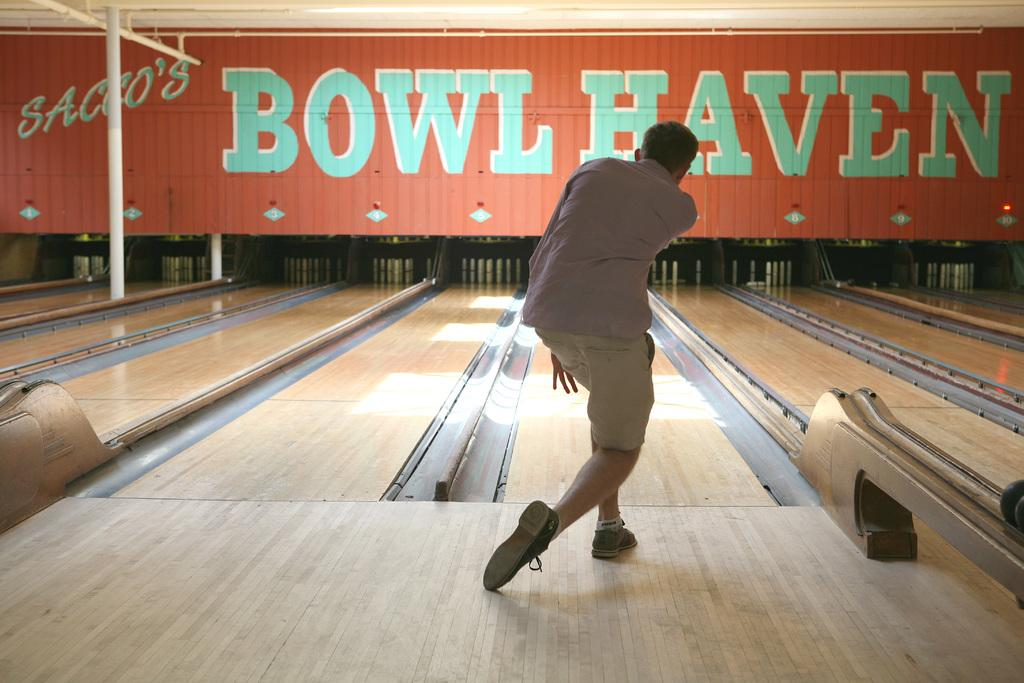What is the main subject of the image? There is a person standing in the image. What objects are present in the image related to a specific activity? There are bowling pins in the image. What other object can be seen in the image? There is a board in the image. What type of jam is being spread on the board in the image? There is no jam present in the image; the board is likely related to the bowling activity. How does the person's experience in playing volleyball relate to the image? The image does not depict any volleyball-related elements, so the person's experience in playing volleyball is not relevant to the image. 